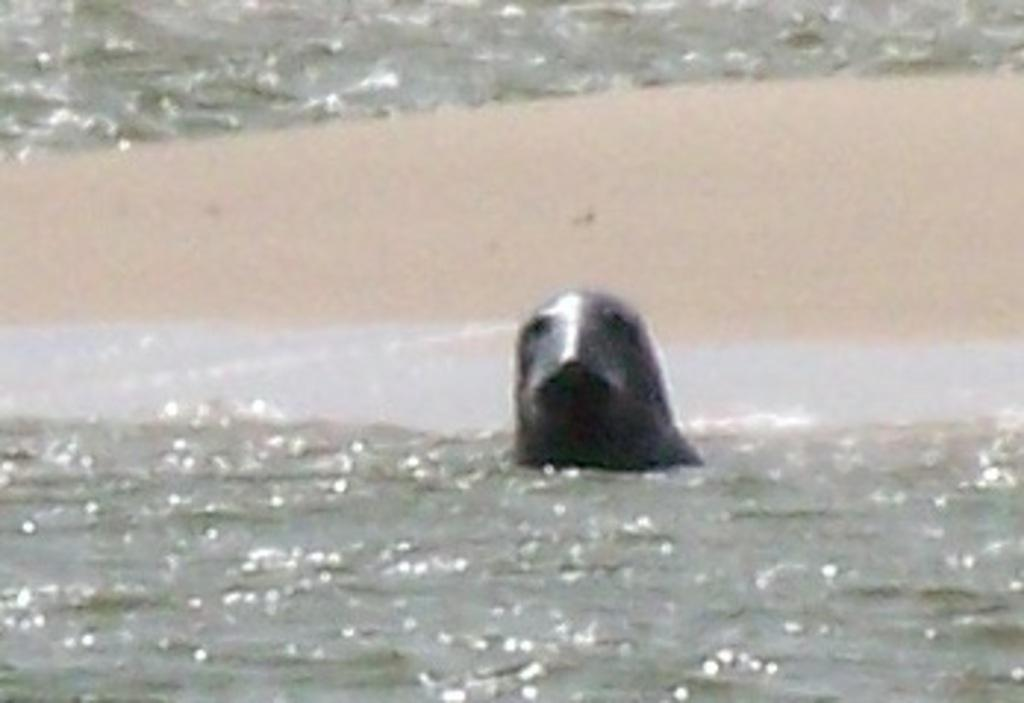What animal is in the image? There is a seal in the image. Where is the seal located? The seal is in the water. How is the seal positioned in the image? The seal is in the center of the image. What type of hair can be seen on the seal in the image? Seals do not have hair, so there is no hair visible on the seal in the image. 